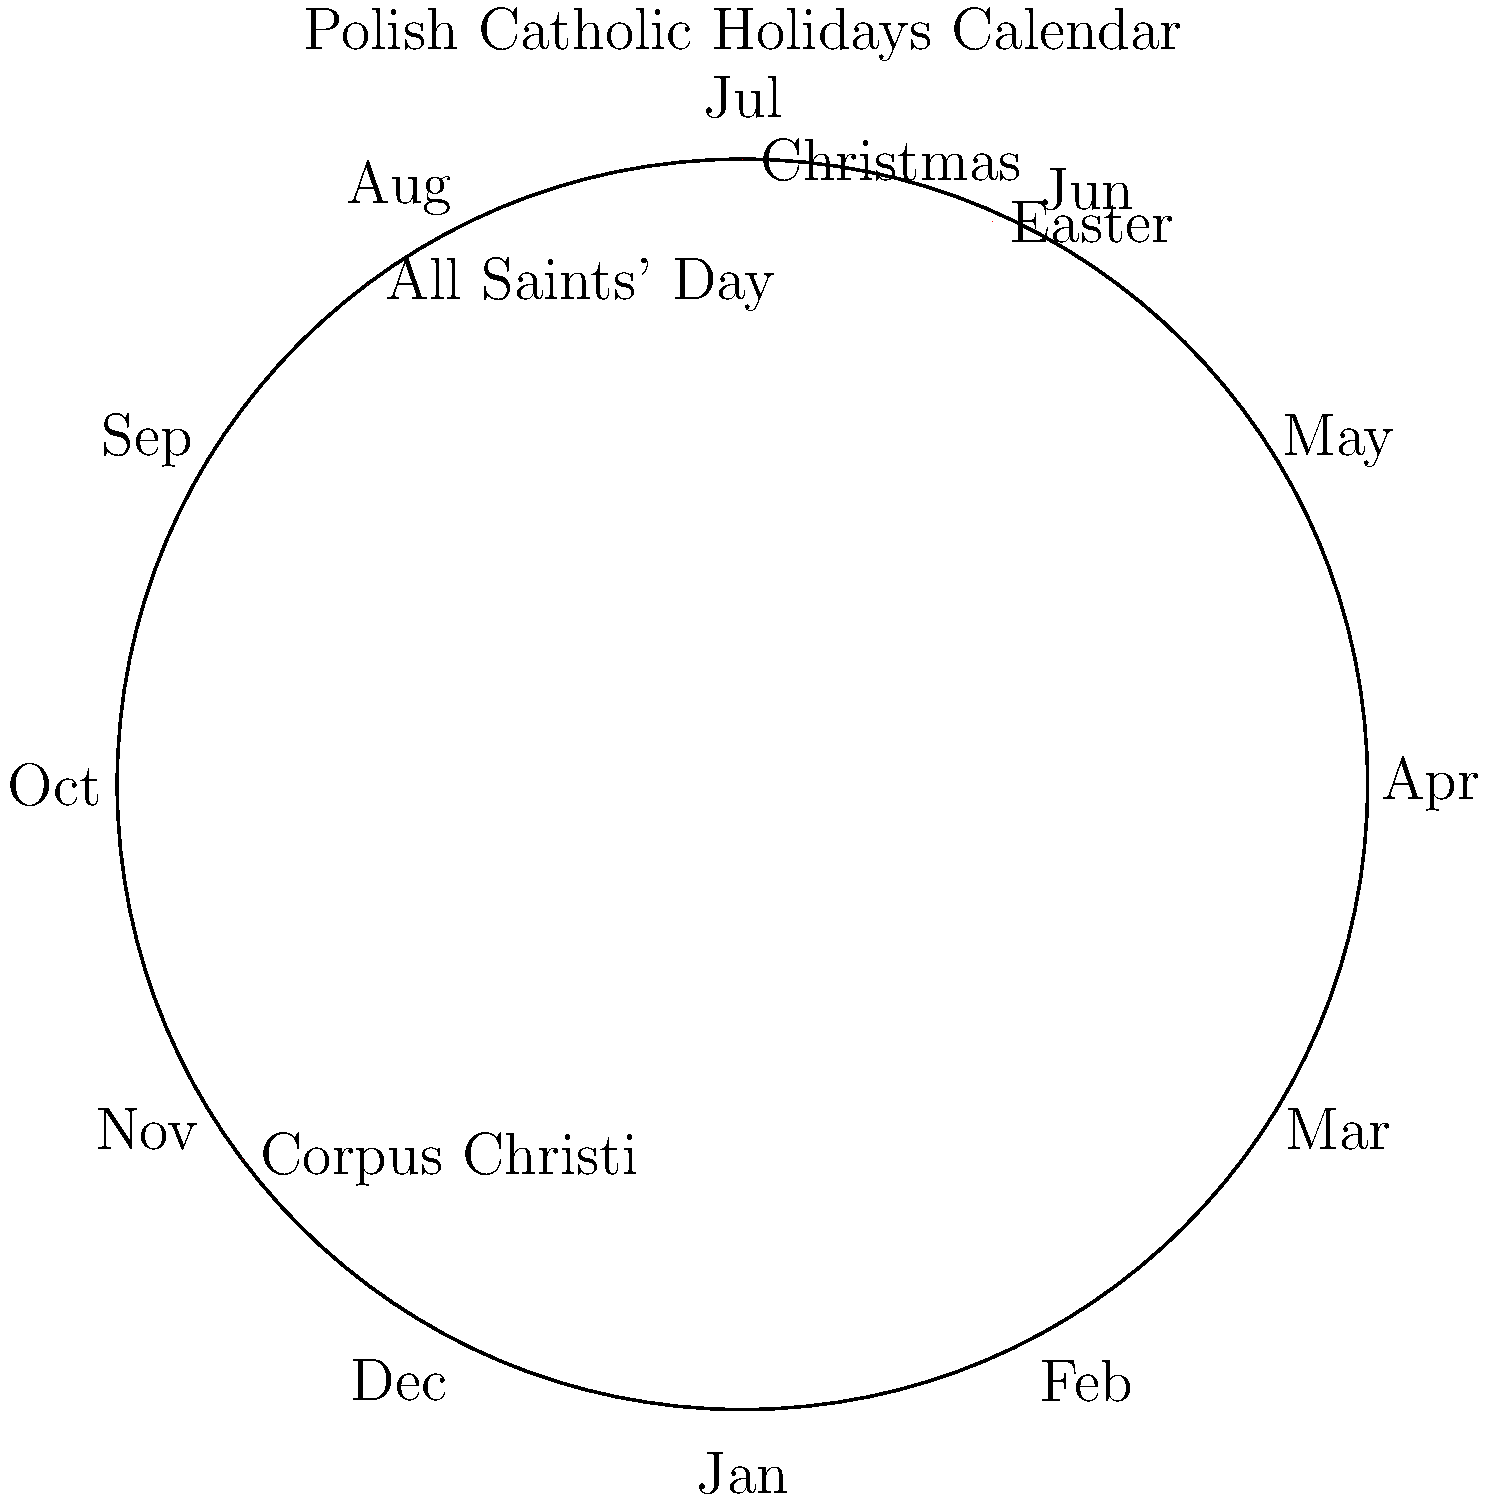Based on the circular calendar diagram of Polish Catholic holidays, which major religious celebration is positioned closest to the beginning of summer, and how does this timing relate to Polish cultural traditions? To answer this question, let's analyze the circular calendar diagram step-by-step:

1. The diagram shows four major Catholic holidays in Poland: Christmas, Easter, Corpus Christi, and All Saints' Day.

2. We need to identify which holiday is closest to the beginning of summer:
   - Christmas is near December (winter)
   - Easter is typically in spring (March or April)
   - Corpus Christi is shown between May and June
   - All Saints' Day is near November (autumn)

3. The beginning of summer is around June 21st (summer solstice). 

4. Corpus Christi is positioned closest to June, making it the holiday closest to the beginning of summer.

5. Corpus Christi (Boże Ciało in Polish) is a moveable feast that occurs 60 days after Easter Sunday, typically in late May or early June.

6. This timing relates to Polish cultural traditions in several ways:
   - It marks the beginning of the summer festival season in Poland.
   - Many towns and villages organize colorful processions with flower petals, banners, and traditional costumes.
   - It's often associated with the harvest season, as fields are in full bloom at this time.
   - Traditionally, branches blessed during the Corpus Christi procession were believed to protect crops and homes from natural disasters.

7. The celebration of Corpus Christi in Poland demonstrates the strong intertwining of Catholic religious observances with Polish cultural and folk traditions, especially those related to agriculture and community gatherings.
Answer: Corpus Christi; it marks the start of summer festivals and incorporates agricultural folk traditions. 